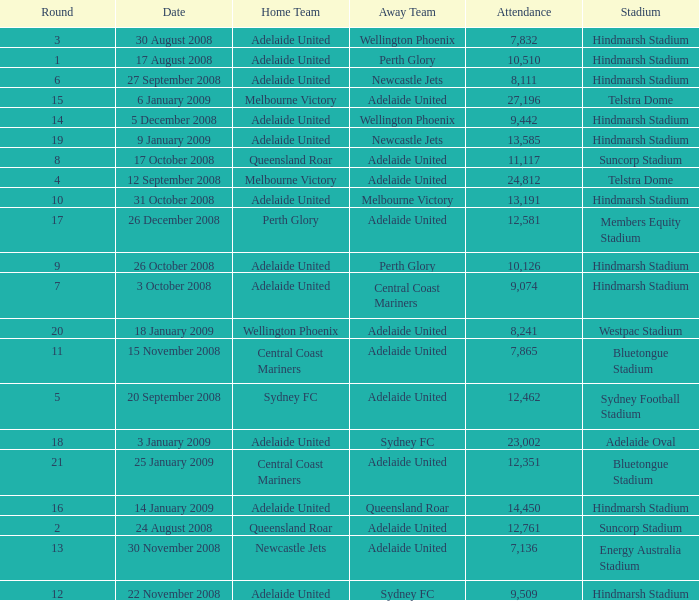Who was the away team when Queensland Roar was the home team in the round less than 3? Adelaide United. 